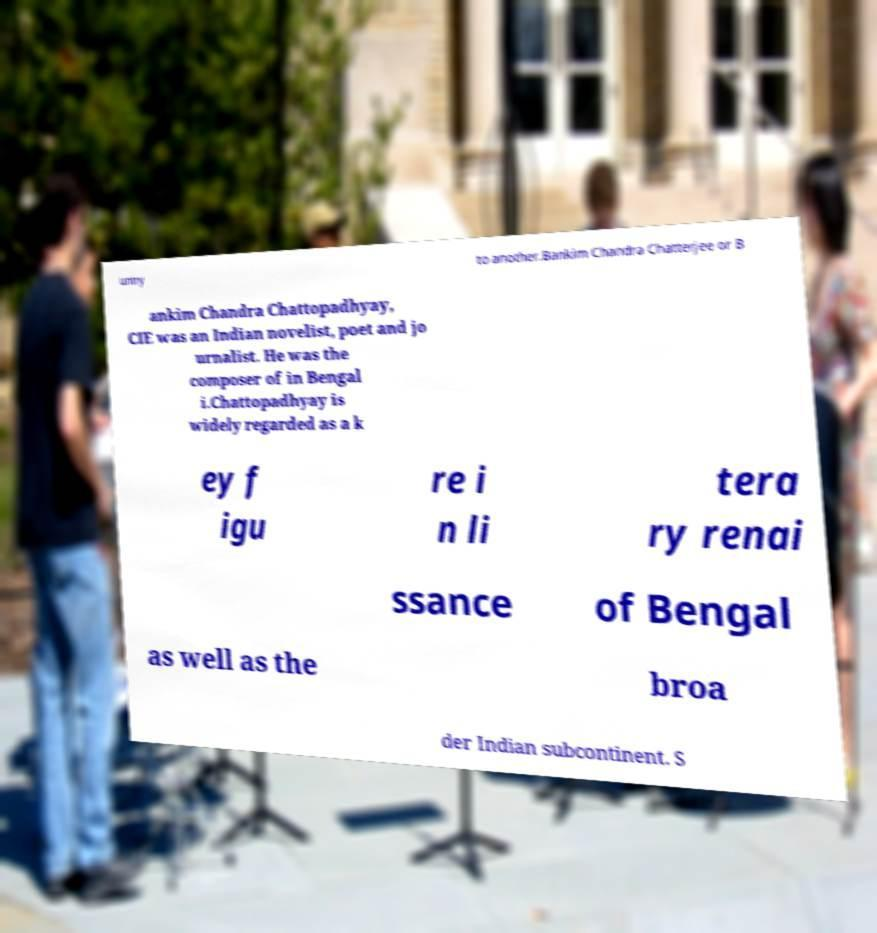What messages or text are displayed in this image? I need them in a readable, typed format. untry to another.Bankim Chandra Chatterjee or B ankim Chandra Chattopadhyay, CIE was an Indian novelist, poet and jo urnalist. He was the composer of in Bengal i.Chattopadhyay is widely regarded as a k ey f igu re i n li tera ry renai ssance of Bengal as well as the broa der Indian subcontinent. S 